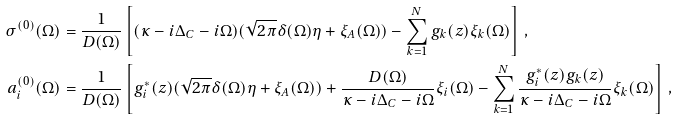Convert formula to latex. <formula><loc_0><loc_0><loc_500><loc_500>\sigma ^ { ( 0 ) } ( \Omega ) & = \frac { 1 } { D ( \Omega ) } \left [ ( \kappa - i \Delta _ { C } - i \Omega ) ( \sqrt { 2 \pi } \delta ( \Omega ) \eta + \xi _ { A } ( \Omega ) ) - \sum _ { k = 1 } ^ { N } g _ { k } ( z ) \xi _ { k } ( \Omega ) \right ] \, , \\ a _ { i } ^ { ( 0 ) } ( \Omega ) & = \frac { 1 } { D ( \Omega ) } \left [ g _ { i } ^ { * } ( z ) ( \sqrt { 2 \pi } \delta ( \Omega ) \eta + \xi _ { A } ( \Omega ) ) + \frac { D ( \Omega ) } { \kappa - i \Delta _ { C } - i \Omega } \xi _ { i } ( \Omega ) - \sum _ { k = 1 } ^ { N } \frac { g _ { i } ^ { * } ( z ) g _ { k } ( z ) } { \kappa - i \Delta _ { C } - i \Omega } \xi _ { k } ( \Omega ) \right ] \, ,</formula> 